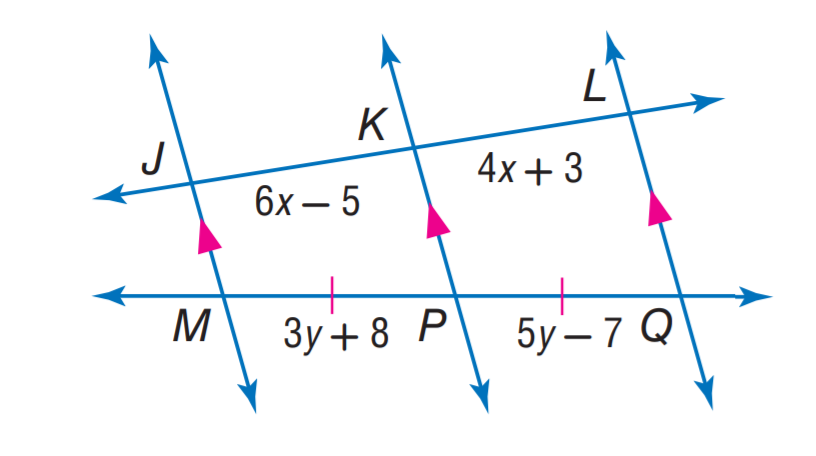Answer the mathemtical geometry problem and directly provide the correct option letter.
Question: Find x.
Choices: A: 3 B: 4 C: 6 D: 7 B 